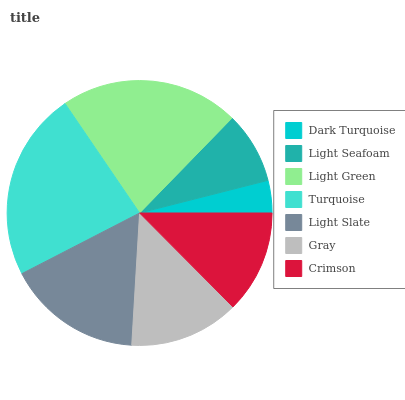Is Dark Turquoise the minimum?
Answer yes or no. Yes. Is Turquoise the maximum?
Answer yes or no. Yes. Is Light Seafoam the minimum?
Answer yes or no. No. Is Light Seafoam the maximum?
Answer yes or no. No. Is Light Seafoam greater than Dark Turquoise?
Answer yes or no. Yes. Is Dark Turquoise less than Light Seafoam?
Answer yes or no. Yes. Is Dark Turquoise greater than Light Seafoam?
Answer yes or no. No. Is Light Seafoam less than Dark Turquoise?
Answer yes or no. No. Is Gray the high median?
Answer yes or no. Yes. Is Gray the low median?
Answer yes or no. Yes. Is Light Seafoam the high median?
Answer yes or no. No. Is Light Slate the low median?
Answer yes or no. No. 